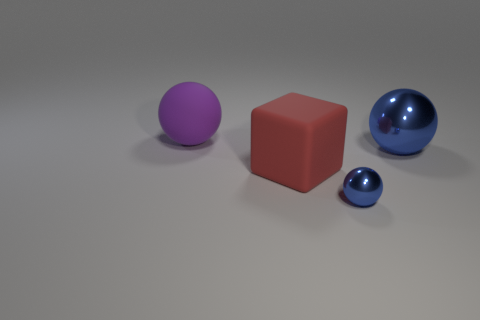What number of things are either matte objects in front of the big blue metallic sphere or tiny gray shiny things?
Your answer should be compact. 1. There is a sphere that is to the left of the big metal ball and in front of the large purple ball; how big is it?
Give a very brief answer. Small. What is the size of the other metallic thing that is the same color as the big metal thing?
Your answer should be compact. Small. What number of other things are the same size as the red cube?
Provide a short and direct response. 2. There is a large sphere on the left side of the metal ball in front of the large ball on the right side of the tiny ball; what is its color?
Offer a very short reply. Purple. The object that is both behind the small blue object and in front of the big metallic ball has what shape?
Your answer should be compact. Cube. How many other objects are the same shape as the small metallic thing?
Your answer should be very brief. 2. There is a large matte object that is behind the metallic object behind the red rubber block that is behind the tiny sphere; what shape is it?
Offer a very short reply. Sphere. How many objects are cyan matte cubes or metallic objects in front of the large red cube?
Give a very brief answer. 1. There is a shiny object that is to the right of the small shiny thing; is its shape the same as the rubber thing that is on the left side of the big red rubber block?
Provide a succinct answer. Yes. 